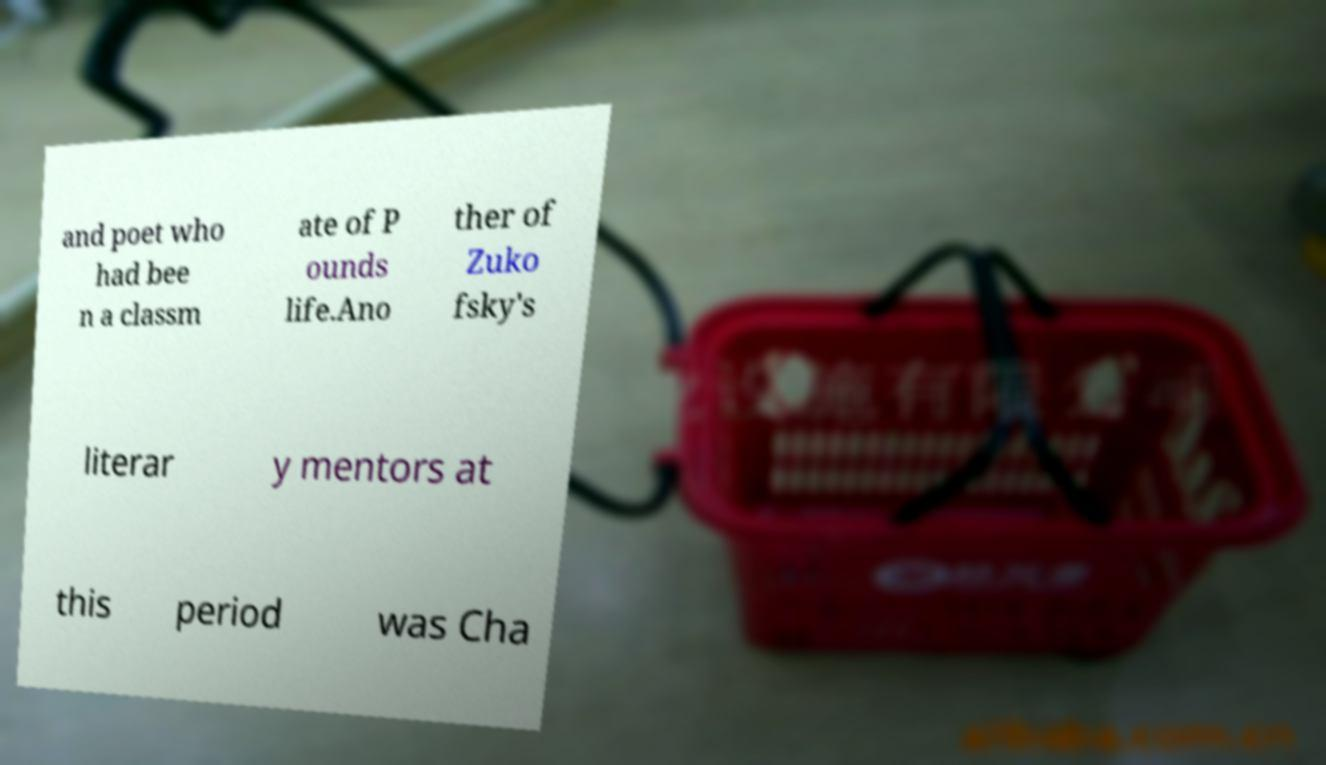Can you read and provide the text displayed in the image?This photo seems to have some interesting text. Can you extract and type it out for me? and poet who had bee n a classm ate of P ounds life.Ano ther of Zuko fsky's literar y mentors at this period was Cha 